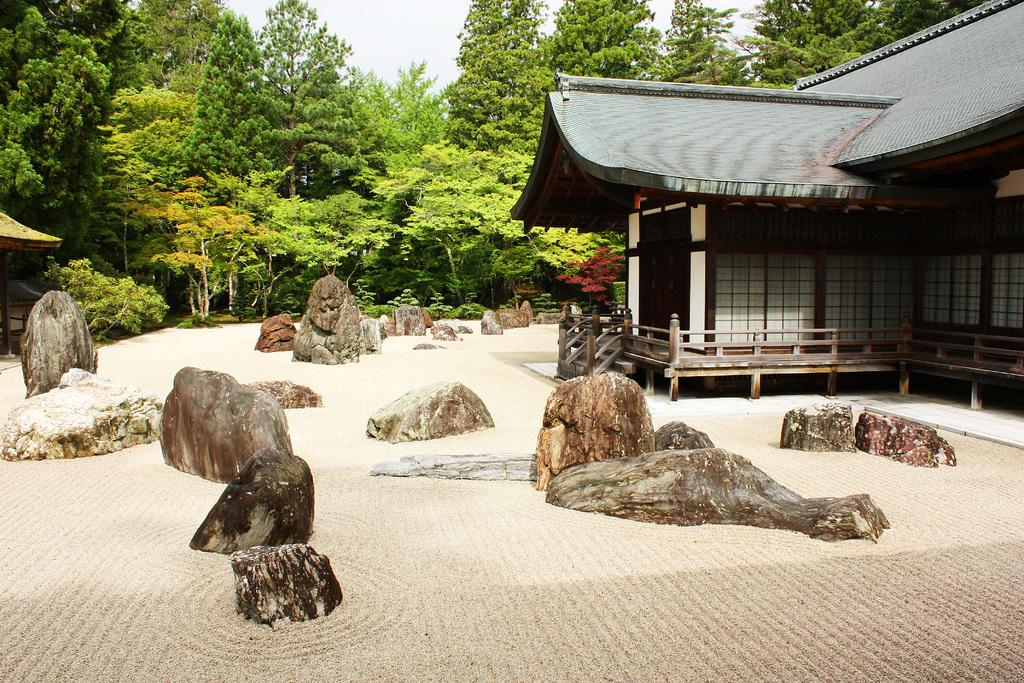What structure is located towards the right side of the image? There is a house towards the right side of the image. What is in front of the house in the image? There are stones in front of the house. What type of vegetation can be seen in the background of the image? There are trees in the background of the image. What is visible in the background of the image besides the trees? The sky is visible in the background of the image. How many friends are playing with the balls in the yard in the image? There is no yard, friends, or balls present in the image. 